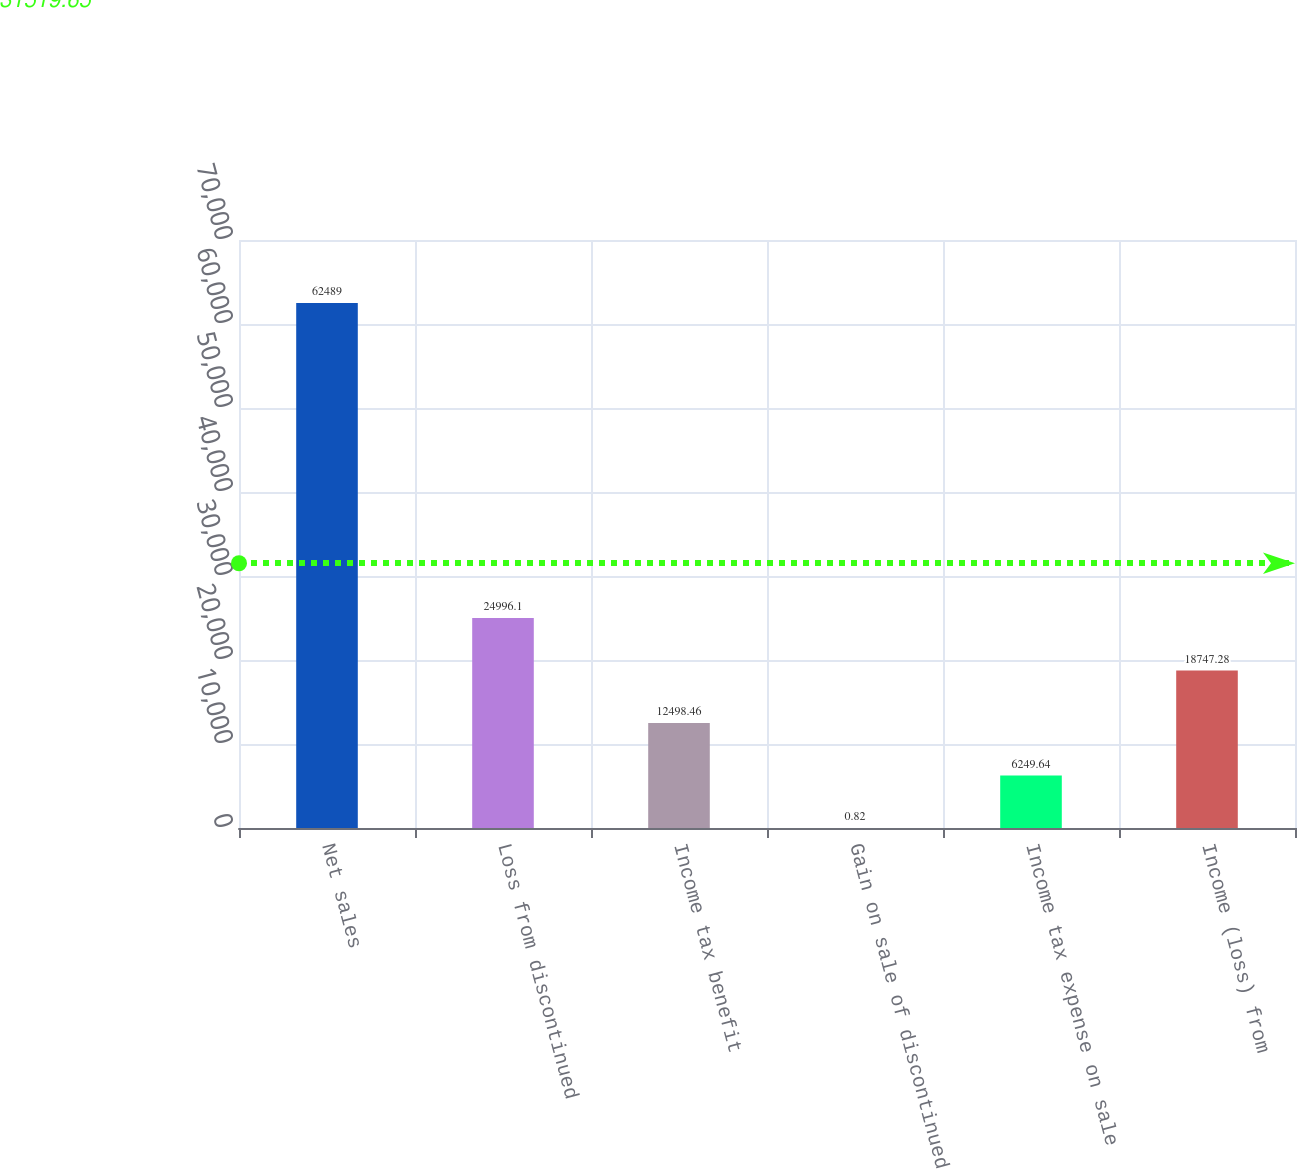Convert chart to OTSL. <chart><loc_0><loc_0><loc_500><loc_500><bar_chart><fcel>Net sales<fcel>Loss from discontinued<fcel>Income tax benefit<fcel>Gain on sale of discontinued<fcel>Income tax expense on sale<fcel>Income (loss) from<nl><fcel>62489<fcel>24996.1<fcel>12498.5<fcel>0.82<fcel>6249.64<fcel>18747.3<nl></chart> 